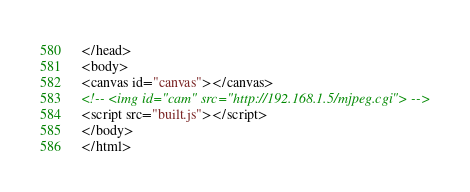<code> <loc_0><loc_0><loc_500><loc_500><_HTML_></head>
<body>
<canvas id="canvas"></canvas>
<!-- <img id="cam" src="http://192.168.1.5/mjpeg.cgi"> -->
<script src="built.js"></script>
</body>
</html></code> 